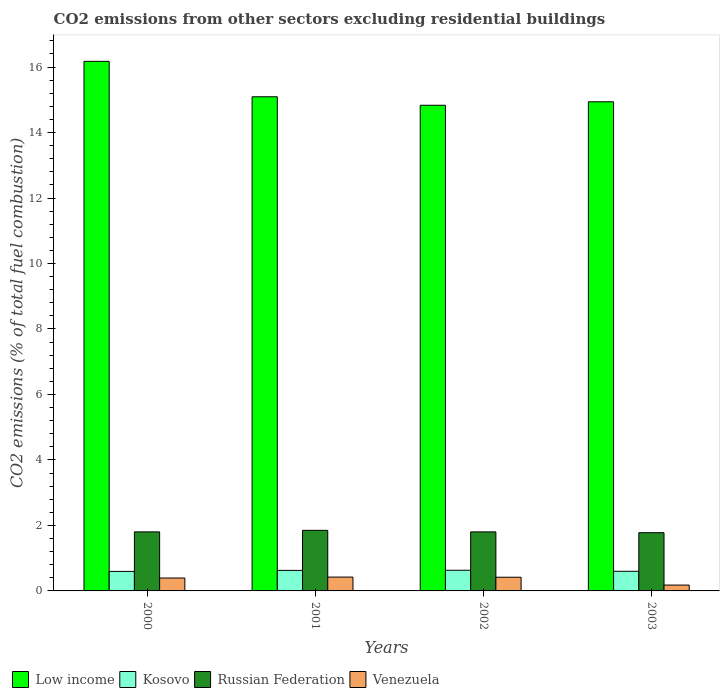How many different coloured bars are there?
Ensure brevity in your answer.  4. Are the number of bars on each tick of the X-axis equal?
Your answer should be very brief. Yes. In how many cases, is the number of bars for a given year not equal to the number of legend labels?
Offer a terse response. 0. What is the total CO2 emitted in Kosovo in 2002?
Ensure brevity in your answer.  0.63. Across all years, what is the maximum total CO2 emitted in Russian Federation?
Give a very brief answer. 1.85. Across all years, what is the minimum total CO2 emitted in Venezuela?
Provide a succinct answer. 0.18. What is the total total CO2 emitted in Kosovo in the graph?
Offer a very short reply. 2.45. What is the difference between the total CO2 emitted in Kosovo in 2001 and that in 2002?
Make the answer very short. -0. What is the difference between the total CO2 emitted in Kosovo in 2000 and the total CO2 emitted in Russian Federation in 2002?
Provide a succinct answer. -1.21. What is the average total CO2 emitted in Kosovo per year?
Make the answer very short. 0.61. In the year 2000, what is the difference between the total CO2 emitted in Venezuela and total CO2 emitted in Kosovo?
Give a very brief answer. -0.2. What is the ratio of the total CO2 emitted in Venezuela in 2000 to that in 2002?
Your response must be concise. 0.94. Is the difference between the total CO2 emitted in Venezuela in 2000 and 2002 greater than the difference between the total CO2 emitted in Kosovo in 2000 and 2002?
Give a very brief answer. Yes. What is the difference between the highest and the second highest total CO2 emitted in Kosovo?
Provide a succinct answer. 0. What is the difference between the highest and the lowest total CO2 emitted in Russian Federation?
Ensure brevity in your answer.  0.07. What does the 4th bar from the left in 2002 represents?
Give a very brief answer. Venezuela. What does the 4th bar from the right in 2000 represents?
Give a very brief answer. Low income. Is it the case that in every year, the sum of the total CO2 emitted in Russian Federation and total CO2 emitted in Low income is greater than the total CO2 emitted in Kosovo?
Offer a terse response. Yes. How many years are there in the graph?
Offer a terse response. 4. What is the difference between two consecutive major ticks on the Y-axis?
Provide a succinct answer. 2. Are the values on the major ticks of Y-axis written in scientific E-notation?
Provide a succinct answer. No. How many legend labels are there?
Keep it short and to the point. 4. How are the legend labels stacked?
Ensure brevity in your answer.  Horizontal. What is the title of the graph?
Ensure brevity in your answer.  CO2 emissions from other sectors excluding residential buildings. Does "Cote d'Ivoire" appear as one of the legend labels in the graph?
Give a very brief answer. No. What is the label or title of the X-axis?
Offer a very short reply. Years. What is the label or title of the Y-axis?
Offer a terse response. CO2 emissions (% of total fuel combustion). What is the CO2 emissions (% of total fuel combustion) in Low income in 2000?
Keep it short and to the point. 16.17. What is the CO2 emissions (% of total fuel combustion) of Kosovo in 2000?
Your answer should be very brief. 0.6. What is the CO2 emissions (% of total fuel combustion) of Russian Federation in 2000?
Provide a short and direct response. 1.8. What is the CO2 emissions (% of total fuel combustion) of Venezuela in 2000?
Offer a very short reply. 0.39. What is the CO2 emissions (% of total fuel combustion) in Low income in 2001?
Your response must be concise. 15.09. What is the CO2 emissions (% of total fuel combustion) of Kosovo in 2001?
Give a very brief answer. 0.63. What is the CO2 emissions (% of total fuel combustion) in Russian Federation in 2001?
Your answer should be very brief. 1.85. What is the CO2 emissions (% of total fuel combustion) of Venezuela in 2001?
Provide a short and direct response. 0.42. What is the CO2 emissions (% of total fuel combustion) in Low income in 2002?
Your response must be concise. 14.83. What is the CO2 emissions (% of total fuel combustion) in Kosovo in 2002?
Provide a succinct answer. 0.63. What is the CO2 emissions (% of total fuel combustion) in Russian Federation in 2002?
Ensure brevity in your answer.  1.8. What is the CO2 emissions (% of total fuel combustion) in Venezuela in 2002?
Ensure brevity in your answer.  0.42. What is the CO2 emissions (% of total fuel combustion) of Low income in 2003?
Provide a succinct answer. 14.94. What is the CO2 emissions (% of total fuel combustion) of Kosovo in 2003?
Ensure brevity in your answer.  0.6. What is the CO2 emissions (% of total fuel combustion) in Russian Federation in 2003?
Make the answer very short. 1.78. What is the CO2 emissions (% of total fuel combustion) in Venezuela in 2003?
Give a very brief answer. 0.18. Across all years, what is the maximum CO2 emissions (% of total fuel combustion) in Low income?
Offer a terse response. 16.17. Across all years, what is the maximum CO2 emissions (% of total fuel combustion) in Kosovo?
Offer a terse response. 0.63. Across all years, what is the maximum CO2 emissions (% of total fuel combustion) of Russian Federation?
Your answer should be very brief. 1.85. Across all years, what is the maximum CO2 emissions (% of total fuel combustion) of Venezuela?
Make the answer very short. 0.42. Across all years, what is the minimum CO2 emissions (% of total fuel combustion) in Low income?
Provide a succinct answer. 14.83. Across all years, what is the minimum CO2 emissions (% of total fuel combustion) in Kosovo?
Your response must be concise. 0.6. Across all years, what is the minimum CO2 emissions (% of total fuel combustion) in Russian Federation?
Offer a very short reply. 1.78. Across all years, what is the minimum CO2 emissions (% of total fuel combustion) in Venezuela?
Offer a terse response. 0.18. What is the total CO2 emissions (% of total fuel combustion) in Low income in the graph?
Ensure brevity in your answer.  61.04. What is the total CO2 emissions (% of total fuel combustion) in Kosovo in the graph?
Keep it short and to the point. 2.45. What is the total CO2 emissions (% of total fuel combustion) in Russian Federation in the graph?
Keep it short and to the point. 7.24. What is the total CO2 emissions (% of total fuel combustion) of Venezuela in the graph?
Your answer should be compact. 1.41. What is the difference between the CO2 emissions (% of total fuel combustion) in Low income in 2000 and that in 2001?
Provide a succinct answer. 1.08. What is the difference between the CO2 emissions (% of total fuel combustion) of Kosovo in 2000 and that in 2001?
Provide a short and direct response. -0.03. What is the difference between the CO2 emissions (% of total fuel combustion) in Russian Federation in 2000 and that in 2001?
Your response must be concise. -0.05. What is the difference between the CO2 emissions (% of total fuel combustion) in Venezuela in 2000 and that in 2001?
Your response must be concise. -0.03. What is the difference between the CO2 emissions (% of total fuel combustion) in Low income in 2000 and that in 2002?
Your response must be concise. 1.34. What is the difference between the CO2 emissions (% of total fuel combustion) in Kosovo in 2000 and that in 2002?
Your response must be concise. -0.03. What is the difference between the CO2 emissions (% of total fuel combustion) of Russian Federation in 2000 and that in 2002?
Your answer should be very brief. -0. What is the difference between the CO2 emissions (% of total fuel combustion) in Venezuela in 2000 and that in 2002?
Your answer should be very brief. -0.02. What is the difference between the CO2 emissions (% of total fuel combustion) in Low income in 2000 and that in 2003?
Provide a succinct answer. 1.24. What is the difference between the CO2 emissions (% of total fuel combustion) in Kosovo in 2000 and that in 2003?
Your answer should be compact. -0. What is the difference between the CO2 emissions (% of total fuel combustion) in Russian Federation in 2000 and that in 2003?
Your response must be concise. 0.02. What is the difference between the CO2 emissions (% of total fuel combustion) of Venezuela in 2000 and that in 2003?
Your response must be concise. 0.22. What is the difference between the CO2 emissions (% of total fuel combustion) of Low income in 2001 and that in 2002?
Keep it short and to the point. 0.26. What is the difference between the CO2 emissions (% of total fuel combustion) of Kosovo in 2001 and that in 2002?
Make the answer very short. -0. What is the difference between the CO2 emissions (% of total fuel combustion) in Russian Federation in 2001 and that in 2002?
Offer a very short reply. 0.05. What is the difference between the CO2 emissions (% of total fuel combustion) of Venezuela in 2001 and that in 2002?
Offer a terse response. 0. What is the difference between the CO2 emissions (% of total fuel combustion) of Low income in 2001 and that in 2003?
Offer a terse response. 0.15. What is the difference between the CO2 emissions (% of total fuel combustion) of Kosovo in 2001 and that in 2003?
Your answer should be compact. 0.03. What is the difference between the CO2 emissions (% of total fuel combustion) in Russian Federation in 2001 and that in 2003?
Your response must be concise. 0.07. What is the difference between the CO2 emissions (% of total fuel combustion) of Venezuela in 2001 and that in 2003?
Your response must be concise. 0.24. What is the difference between the CO2 emissions (% of total fuel combustion) of Low income in 2002 and that in 2003?
Provide a short and direct response. -0.11. What is the difference between the CO2 emissions (% of total fuel combustion) of Kosovo in 2002 and that in 2003?
Keep it short and to the point. 0.03. What is the difference between the CO2 emissions (% of total fuel combustion) in Russian Federation in 2002 and that in 2003?
Your answer should be compact. 0.02. What is the difference between the CO2 emissions (% of total fuel combustion) in Venezuela in 2002 and that in 2003?
Your response must be concise. 0.24. What is the difference between the CO2 emissions (% of total fuel combustion) of Low income in 2000 and the CO2 emissions (% of total fuel combustion) of Kosovo in 2001?
Offer a terse response. 15.55. What is the difference between the CO2 emissions (% of total fuel combustion) in Low income in 2000 and the CO2 emissions (% of total fuel combustion) in Russian Federation in 2001?
Your response must be concise. 14.32. What is the difference between the CO2 emissions (% of total fuel combustion) of Low income in 2000 and the CO2 emissions (% of total fuel combustion) of Venezuela in 2001?
Make the answer very short. 15.75. What is the difference between the CO2 emissions (% of total fuel combustion) in Kosovo in 2000 and the CO2 emissions (% of total fuel combustion) in Russian Federation in 2001?
Provide a succinct answer. -1.25. What is the difference between the CO2 emissions (% of total fuel combustion) in Kosovo in 2000 and the CO2 emissions (% of total fuel combustion) in Venezuela in 2001?
Offer a very short reply. 0.17. What is the difference between the CO2 emissions (% of total fuel combustion) of Russian Federation in 2000 and the CO2 emissions (% of total fuel combustion) of Venezuela in 2001?
Give a very brief answer. 1.38. What is the difference between the CO2 emissions (% of total fuel combustion) in Low income in 2000 and the CO2 emissions (% of total fuel combustion) in Kosovo in 2002?
Give a very brief answer. 15.54. What is the difference between the CO2 emissions (% of total fuel combustion) of Low income in 2000 and the CO2 emissions (% of total fuel combustion) of Russian Federation in 2002?
Provide a succinct answer. 14.37. What is the difference between the CO2 emissions (% of total fuel combustion) of Low income in 2000 and the CO2 emissions (% of total fuel combustion) of Venezuela in 2002?
Your answer should be very brief. 15.76. What is the difference between the CO2 emissions (% of total fuel combustion) in Kosovo in 2000 and the CO2 emissions (% of total fuel combustion) in Russian Federation in 2002?
Provide a succinct answer. -1.21. What is the difference between the CO2 emissions (% of total fuel combustion) in Kosovo in 2000 and the CO2 emissions (% of total fuel combustion) in Venezuela in 2002?
Provide a short and direct response. 0.18. What is the difference between the CO2 emissions (% of total fuel combustion) of Russian Federation in 2000 and the CO2 emissions (% of total fuel combustion) of Venezuela in 2002?
Keep it short and to the point. 1.39. What is the difference between the CO2 emissions (% of total fuel combustion) in Low income in 2000 and the CO2 emissions (% of total fuel combustion) in Kosovo in 2003?
Your answer should be compact. 15.57. What is the difference between the CO2 emissions (% of total fuel combustion) of Low income in 2000 and the CO2 emissions (% of total fuel combustion) of Russian Federation in 2003?
Your response must be concise. 14.4. What is the difference between the CO2 emissions (% of total fuel combustion) of Low income in 2000 and the CO2 emissions (% of total fuel combustion) of Venezuela in 2003?
Give a very brief answer. 16. What is the difference between the CO2 emissions (% of total fuel combustion) in Kosovo in 2000 and the CO2 emissions (% of total fuel combustion) in Russian Federation in 2003?
Your answer should be compact. -1.18. What is the difference between the CO2 emissions (% of total fuel combustion) in Kosovo in 2000 and the CO2 emissions (% of total fuel combustion) in Venezuela in 2003?
Provide a short and direct response. 0.42. What is the difference between the CO2 emissions (% of total fuel combustion) in Russian Federation in 2000 and the CO2 emissions (% of total fuel combustion) in Venezuela in 2003?
Your answer should be compact. 1.62. What is the difference between the CO2 emissions (% of total fuel combustion) of Low income in 2001 and the CO2 emissions (% of total fuel combustion) of Kosovo in 2002?
Ensure brevity in your answer.  14.46. What is the difference between the CO2 emissions (% of total fuel combustion) in Low income in 2001 and the CO2 emissions (% of total fuel combustion) in Russian Federation in 2002?
Give a very brief answer. 13.29. What is the difference between the CO2 emissions (% of total fuel combustion) in Low income in 2001 and the CO2 emissions (% of total fuel combustion) in Venezuela in 2002?
Offer a very short reply. 14.67. What is the difference between the CO2 emissions (% of total fuel combustion) in Kosovo in 2001 and the CO2 emissions (% of total fuel combustion) in Russian Federation in 2002?
Give a very brief answer. -1.18. What is the difference between the CO2 emissions (% of total fuel combustion) of Kosovo in 2001 and the CO2 emissions (% of total fuel combustion) of Venezuela in 2002?
Ensure brevity in your answer.  0.21. What is the difference between the CO2 emissions (% of total fuel combustion) of Russian Federation in 2001 and the CO2 emissions (% of total fuel combustion) of Venezuela in 2002?
Ensure brevity in your answer.  1.43. What is the difference between the CO2 emissions (% of total fuel combustion) in Low income in 2001 and the CO2 emissions (% of total fuel combustion) in Kosovo in 2003?
Offer a very short reply. 14.49. What is the difference between the CO2 emissions (% of total fuel combustion) of Low income in 2001 and the CO2 emissions (% of total fuel combustion) of Russian Federation in 2003?
Your response must be concise. 13.31. What is the difference between the CO2 emissions (% of total fuel combustion) in Low income in 2001 and the CO2 emissions (% of total fuel combustion) in Venezuela in 2003?
Provide a succinct answer. 14.91. What is the difference between the CO2 emissions (% of total fuel combustion) of Kosovo in 2001 and the CO2 emissions (% of total fuel combustion) of Russian Federation in 2003?
Ensure brevity in your answer.  -1.15. What is the difference between the CO2 emissions (% of total fuel combustion) in Kosovo in 2001 and the CO2 emissions (% of total fuel combustion) in Venezuela in 2003?
Provide a short and direct response. 0.45. What is the difference between the CO2 emissions (% of total fuel combustion) of Russian Federation in 2001 and the CO2 emissions (% of total fuel combustion) of Venezuela in 2003?
Offer a terse response. 1.67. What is the difference between the CO2 emissions (% of total fuel combustion) in Low income in 2002 and the CO2 emissions (% of total fuel combustion) in Kosovo in 2003?
Provide a succinct answer. 14.23. What is the difference between the CO2 emissions (% of total fuel combustion) in Low income in 2002 and the CO2 emissions (% of total fuel combustion) in Russian Federation in 2003?
Offer a very short reply. 13.05. What is the difference between the CO2 emissions (% of total fuel combustion) in Low income in 2002 and the CO2 emissions (% of total fuel combustion) in Venezuela in 2003?
Provide a short and direct response. 14.65. What is the difference between the CO2 emissions (% of total fuel combustion) in Kosovo in 2002 and the CO2 emissions (% of total fuel combustion) in Russian Federation in 2003?
Your response must be concise. -1.15. What is the difference between the CO2 emissions (% of total fuel combustion) of Kosovo in 2002 and the CO2 emissions (% of total fuel combustion) of Venezuela in 2003?
Make the answer very short. 0.45. What is the difference between the CO2 emissions (% of total fuel combustion) in Russian Federation in 2002 and the CO2 emissions (% of total fuel combustion) in Venezuela in 2003?
Provide a short and direct response. 1.62. What is the average CO2 emissions (% of total fuel combustion) of Low income per year?
Your answer should be compact. 15.26. What is the average CO2 emissions (% of total fuel combustion) in Kosovo per year?
Provide a short and direct response. 0.61. What is the average CO2 emissions (% of total fuel combustion) in Russian Federation per year?
Your response must be concise. 1.81. What is the average CO2 emissions (% of total fuel combustion) in Venezuela per year?
Give a very brief answer. 0.35. In the year 2000, what is the difference between the CO2 emissions (% of total fuel combustion) of Low income and CO2 emissions (% of total fuel combustion) of Kosovo?
Your response must be concise. 15.58. In the year 2000, what is the difference between the CO2 emissions (% of total fuel combustion) in Low income and CO2 emissions (% of total fuel combustion) in Russian Federation?
Keep it short and to the point. 14.37. In the year 2000, what is the difference between the CO2 emissions (% of total fuel combustion) in Low income and CO2 emissions (% of total fuel combustion) in Venezuela?
Your answer should be compact. 15.78. In the year 2000, what is the difference between the CO2 emissions (% of total fuel combustion) in Kosovo and CO2 emissions (% of total fuel combustion) in Russian Federation?
Your answer should be very brief. -1.21. In the year 2000, what is the difference between the CO2 emissions (% of total fuel combustion) in Kosovo and CO2 emissions (% of total fuel combustion) in Venezuela?
Keep it short and to the point. 0.2. In the year 2000, what is the difference between the CO2 emissions (% of total fuel combustion) of Russian Federation and CO2 emissions (% of total fuel combustion) of Venezuela?
Your response must be concise. 1.41. In the year 2001, what is the difference between the CO2 emissions (% of total fuel combustion) in Low income and CO2 emissions (% of total fuel combustion) in Kosovo?
Keep it short and to the point. 14.46. In the year 2001, what is the difference between the CO2 emissions (% of total fuel combustion) in Low income and CO2 emissions (% of total fuel combustion) in Russian Federation?
Provide a succinct answer. 13.24. In the year 2001, what is the difference between the CO2 emissions (% of total fuel combustion) of Low income and CO2 emissions (% of total fuel combustion) of Venezuela?
Provide a succinct answer. 14.67. In the year 2001, what is the difference between the CO2 emissions (% of total fuel combustion) of Kosovo and CO2 emissions (% of total fuel combustion) of Russian Federation?
Provide a succinct answer. -1.22. In the year 2001, what is the difference between the CO2 emissions (% of total fuel combustion) in Kosovo and CO2 emissions (% of total fuel combustion) in Venezuela?
Provide a succinct answer. 0.2. In the year 2001, what is the difference between the CO2 emissions (% of total fuel combustion) in Russian Federation and CO2 emissions (% of total fuel combustion) in Venezuela?
Give a very brief answer. 1.43. In the year 2002, what is the difference between the CO2 emissions (% of total fuel combustion) of Low income and CO2 emissions (% of total fuel combustion) of Kosovo?
Your answer should be very brief. 14.2. In the year 2002, what is the difference between the CO2 emissions (% of total fuel combustion) in Low income and CO2 emissions (% of total fuel combustion) in Russian Federation?
Your answer should be compact. 13.03. In the year 2002, what is the difference between the CO2 emissions (% of total fuel combustion) in Low income and CO2 emissions (% of total fuel combustion) in Venezuela?
Your answer should be very brief. 14.41. In the year 2002, what is the difference between the CO2 emissions (% of total fuel combustion) in Kosovo and CO2 emissions (% of total fuel combustion) in Russian Federation?
Provide a succinct answer. -1.17. In the year 2002, what is the difference between the CO2 emissions (% of total fuel combustion) of Kosovo and CO2 emissions (% of total fuel combustion) of Venezuela?
Ensure brevity in your answer.  0.21. In the year 2002, what is the difference between the CO2 emissions (% of total fuel combustion) in Russian Federation and CO2 emissions (% of total fuel combustion) in Venezuela?
Ensure brevity in your answer.  1.39. In the year 2003, what is the difference between the CO2 emissions (% of total fuel combustion) of Low income and CO2 emissions (% of total fuel combustion) of Kosovo?
Keep it short and to the point. 14.34. In the year 2003, what is the difference between the CO2 emissions (% of total fuel combustion) of Low income and CO2 emissions (% of total fuel combustion) of Russian Federation?
Your answer should be compact. 13.16. In the year 2003, what is the difference between the CO2 emissions (% of total fuel combustion) of Low income and CO2 emissions (% of total fuel combustion) of Venezuela?
Offer a very short reply. 14.76. In the year 2003, what is the difference between the CO2 emissions (% of total fuel combustion) in Kosovo and CO2 emissions (% of total fuel combustion) in Russian Federation?
Offer a very short reply. -1.18. In the year 2003, what is the difference between the CO2 emissions (% of total fuel combustion) of Kosovo and CO2 emissions (% of total fuel combustion) of Venezuela?
Provide a succinct answer. 0.42. In the year 2003, what is the difference between the CO2 emissions (% of total fuel combustion) of Russian Federation and CO2 emissions (% of total fuel combustion) of Venezuela?
Keep it short and to the point. 1.6. What is the ratio of the CO2 emissions (% of total fuel combustion) in Low income in 2000 to that in 2001?
Provide a short and direct response. 1.07. What is the ratio of the CO2 emissions (% of total fuel combustion) in Kosovo in 2000 to that in 2001?
Provide a succinct answer. 0.95. What is the ratio of the CO2 emissions (% of total fuel combustion) in Russian Federation in 2000 to that in 2001?
Your answer should be very brief. 0.97. What is the ratio of the CO2 emissions (% of total fuel combustion) in Venezuela in 2000 to that in 2001?
Give a very brief answer. 0.93. What is the ratio of the CO2 emissions (% of total fuel combustion) in Low income in 2000 to that in 2002?
Keep it short and to the point. 1.09. What is the ratio of the CO2 emissions (% of total fuel combustion) of Kosovo in 2000 to that in 2002?
Offer a terse response. 0.95. What is the ratio of the CO2 emissions (% of total fuel combustion) in Russian Federation in 2000 to that in 2002?
Offer a very short reply. 1. What is the ratio of the CO2 emissions (% of total fuel combustion) in Venezuela in 2000 to that in 2002?
Your answer should be compact. 0.94. What is the ratio of the CO2 emissions (% of total fuel combustion) in Low income in 2000 to that in 2003?
Give a very brief answer. 1.08. What is the ratio of the CO2 emissions (% of total fuel combustion) of Kosovo in 2000 to that in 2003?
Keep it short and to the point. 0.99. What is the ratio of the CO2 emissions (% of total fuel combustion) of Russian Federation in 2000 to that in 2003?
Give a very brief answer. 1.01. What is the ratio of the CO2 emissions (% of total fuel combustion) of Venezuela in 2000 to that in 2003?
Provide a short and direct response. 2.21. What is the ratio of the CO2 emissions (% of total fuel combustion) in Low income in 2001 to that in 2002?
Your response must be concise. 1.02. What is the ratio of the CO2 emissions (% of total fuel combustion) in Kosovo in 2001 to that in 2002?
Offer a terse response. 0.99. What is the ratio of the CO2 emissions (% of total fuel combustion) of Russian Federation in 2001 to that in 2002?
Your answer should be compact. 1.03. What is the ratio of the CO2 emissions (% of total fuel combustion) of Venezuela in 2001 to that in 2002?
Your response must be concise. 1.01. What is the ratio of the CO2 emissions (% of total fuel combustion) of Low income in 2001 to that in 2003?
Your response must be concise. 1.01. What is the ratio of the CO2 emissions (% of total fuel combustion) of Kosovo in 2001 to that in 2003?
Your answer should be compact. 1.05. What is the ratio of the CO2 emissions (% of total fuel combustion) of Russian Federation in 2001 to that in 2003?
Your answer should be compact. 1.04. What is the ratio of the CO2 emissions (% of total fuel combustion) of Venezuela in 2001 to that in 2003?
Ensure brevity in your answer.  2.36. What is the ratio of the CO2 emissions (% of total fuel combustion) in Kosovo in 2002 to that in 2003?
Ensure brevity in your answer.  1.05. What is the ratio of the CO2 emissions (% of total fuel combustion) in Russian Federation in 2002 to that in 2003?
Provide a succinct answer. 1.01. What is the ratio of the CO2 emissions (% of total fuel combustion) in Venezuela in 2002 to that in 2003?
Your response must be concise. 2.34. What is the difference between the highest and the second highest CO2 emissions (% of total fuel combustion) of Low income?
Provide a short and direct response. 1.08. What is the difference between the highest and the second highest CO2 emissions (% of total fuel combustion) in Kosovo?
Provide a short and direct response. 0. What is the difference between the highest and the second highest CO2 emissions (% of total fuel combustion) of Russian Federation?
Ensure brevity in your answer.  0.05. What is the difference between the highest and the second highest CO2 emissions (% of total fuel combustion) in Venezuela?
Offer a very short reply. 0. What is the difference between the highest and the lowest CO2 emissions (% of total fuel combustion) in Low income?
Give a very brief answer. 1.34. What is the difference between the highest and the lowest CO2 emissions (% of total fuel combustion) in Kosovo?
Your answer should be very brief. 0.03. What is the difference between the highest and the lowest CO2 emissions (% of total fuel combustion) of Russian Federation?
Offer a very short reply. 0.07. What is the difference between the highest and the lowest CO2 emissions (% of total fuel combustion) of Venezuela?
Keep it short and to the point. 0.24. 